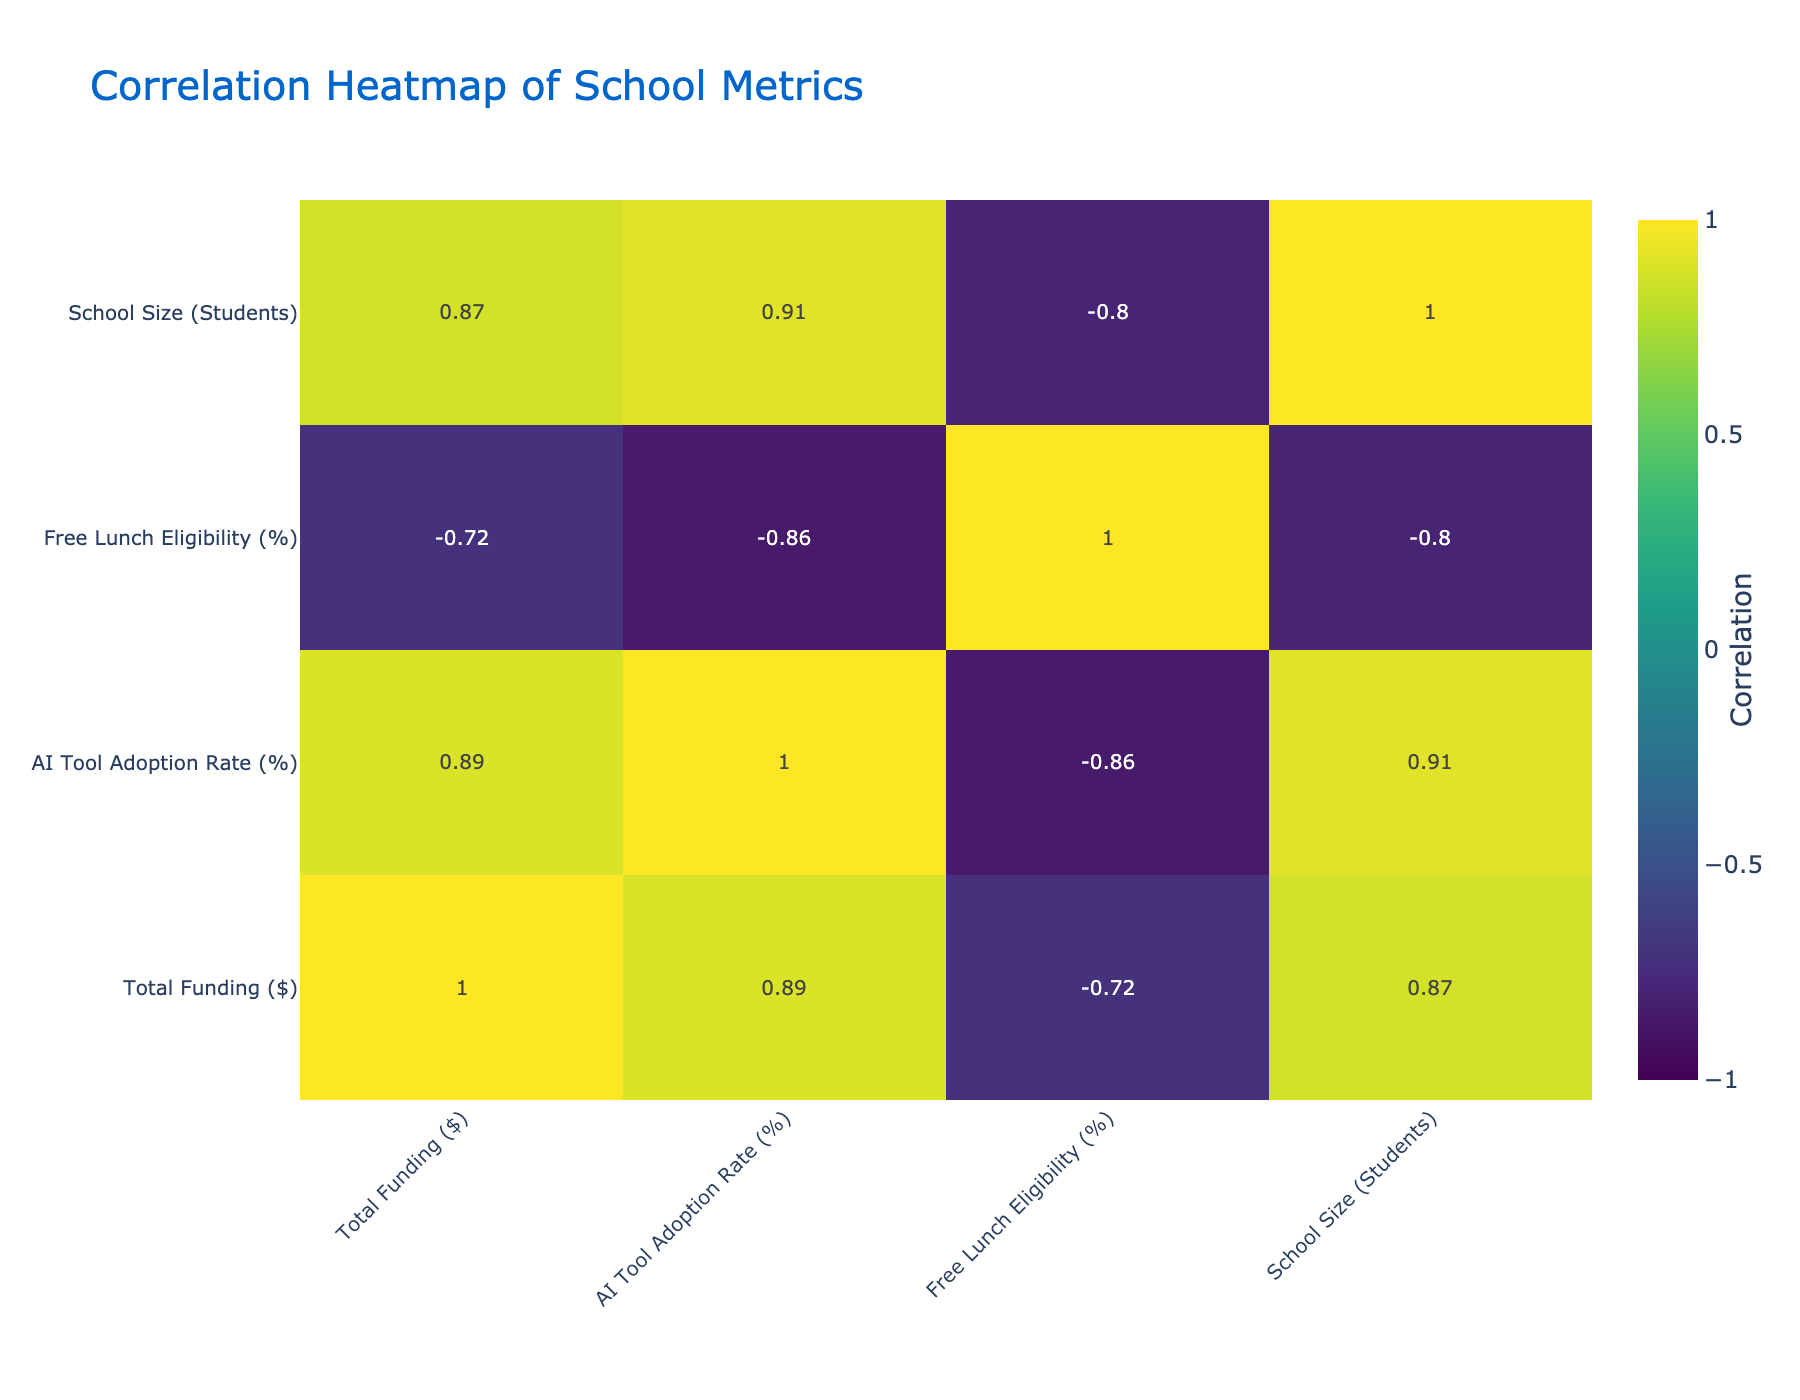What is the AI Tool Adoption Rate for Cherry Blossom High? The table shows that Cherry Blossom High has an AI Tool Adoption Rate of 65%.
Answer: 65 Which school has the highest Total Funding? By comparing the Total Funding values, Maple Valley School has the highest funding amount of $1,500,000.
Answer: $1,500,000 Is there a relationship between Total Funding and AI Tool Adoption Rate? The correlation table indicates a significant positive correlation (0.76), suggesting that higher funding tends to be associated with a higher adoption rate of AI tools.
Answer: Yes What is the average AI Tool Adoption Rate for schools with Free Lunch Eligibility above 50%? The schools eligible for Free Lunch above 50% are Lincoln High, Greenwood High, Bayside High, and Valley Forge Academy. Their AI Tool Adoption Rates are 75%, 70%, 50%, and 55% respectively. Summing these gives 75 + 70 + 50 + 55 = 250. The average is 250/4 = 62.5%.
Answer: 62.5 Which school has the best Student-Teacher Ratio and what is that ratio? The Student-Teacher Ratios are analyzed, and Hillside Academy has the best ratio at 17:1.
Answer: 17:1 Is the AI Tool Adoption Rate for schools in California higher than for those in Texas? Lincoln High School (California) has an adoption rate of 75%, while Greenwood High (Texas) has 70%. The California school’s rate is higher.
Answer: Yes What is the median Total Funding of all the schools listed? The schools' Total Funding amounts are $1,200,000, $800,000, $1,500,000, $950,000, $700,000, $1,100,000, $600,000, $1,300,000, $1,000,000, and $850,000. Arranging these in order gives $600,000, $700,000, $800,000, $850,000, $950,000, $1,000,000, $1,100,000, $1,200,000, $1,300,000, $1,500,000. The median, being the average of the 5th and 6th values, is ($950,000 + $1,000,000) / 2 = $975,000.
Answer: $975,000 Which school has the most students and what is the school size? By looking at the School Size column, Maple Valley School has the most students with a size of 1,000.
Answer: 1,000 What percentage of schools have an AI Tool Adoption Rate below 60%? The schools with an adoption rate below 60% are Riverside Academy (60%), Bayside High School (50%), Cedar Creek School (40%), and Valley Forge Academy (55%). There are 4 out of 10 schools which gives 40%.
Answer: 40% 